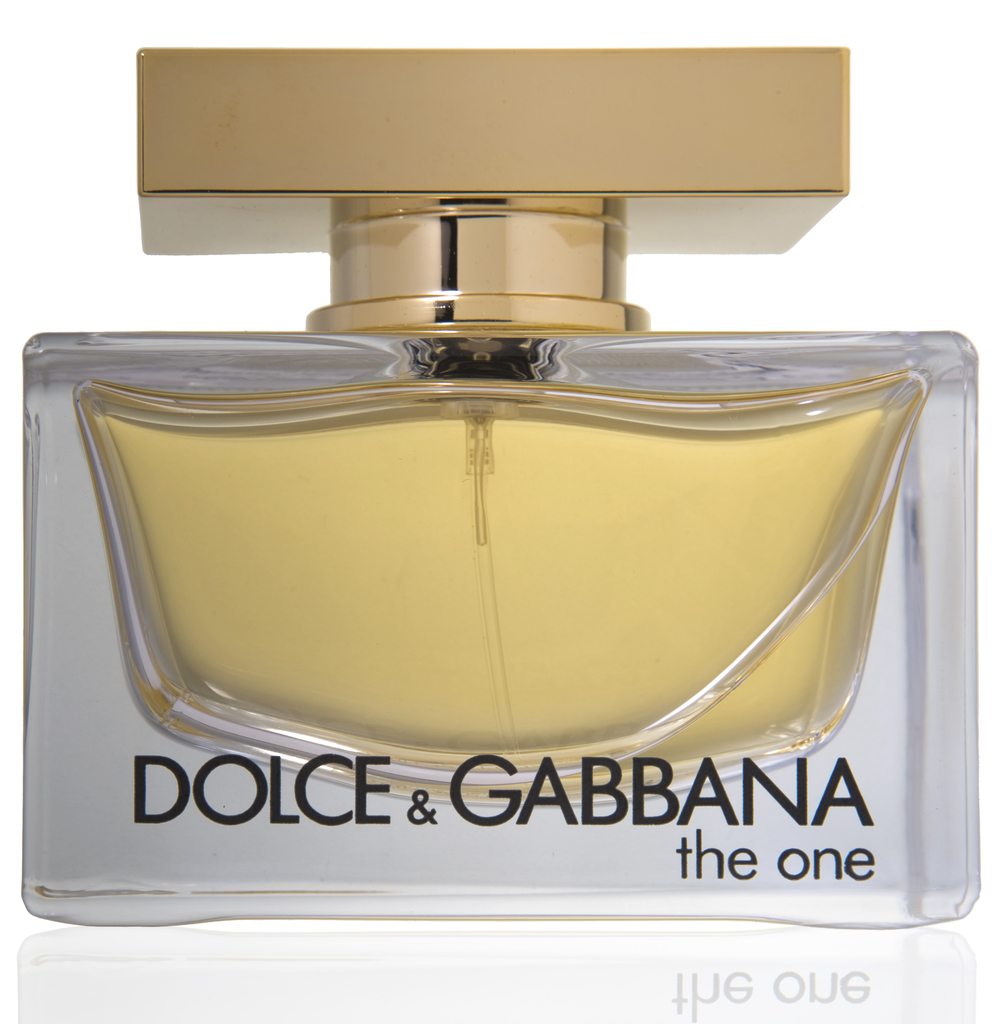Can you explain more about the significance of the color choice for the perfume? The warm yellow hue of the perfume typically suggests richness and warmth, often associated with amber scents which are popular for their deep, earthy, and inviting notes. This color choice not only enhances the visual appeal of the product but may also hint at the type of scent it offers, potentially alluring with hints of exotic spices or sweet floral undertones. It's likely selected to evoke a sense of luxury and comfort, aligning with the overall brand image of Dolce & Gabbana. 